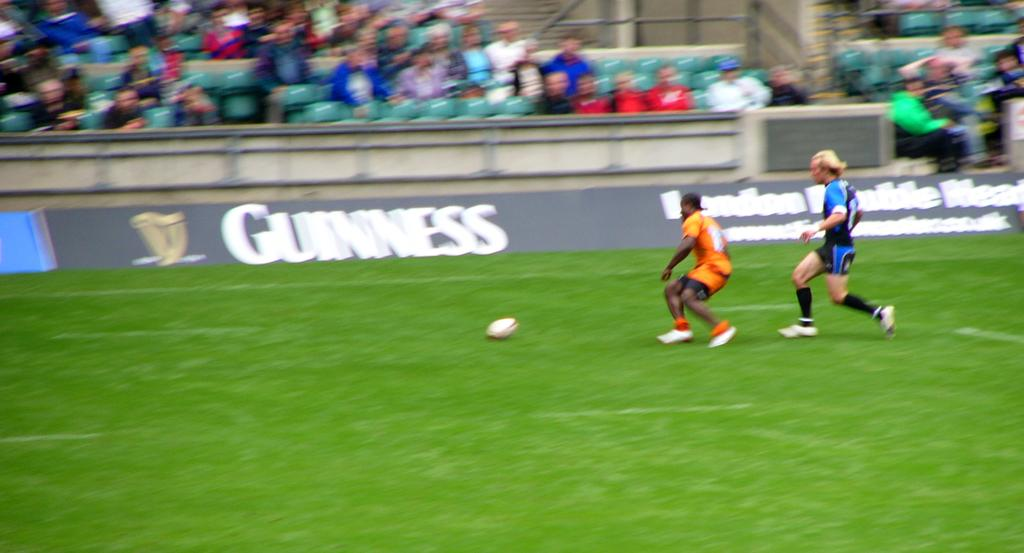<image>
Share a concise interpretation of the image provided. A Guinness sign is on the wall of the soccer field near two players running for the ball. 